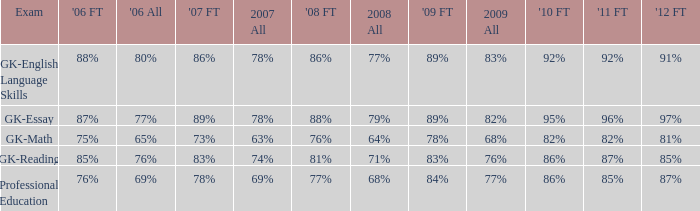What is the percentage for all in 2007 when all in 2006 was 65%? 63%. 